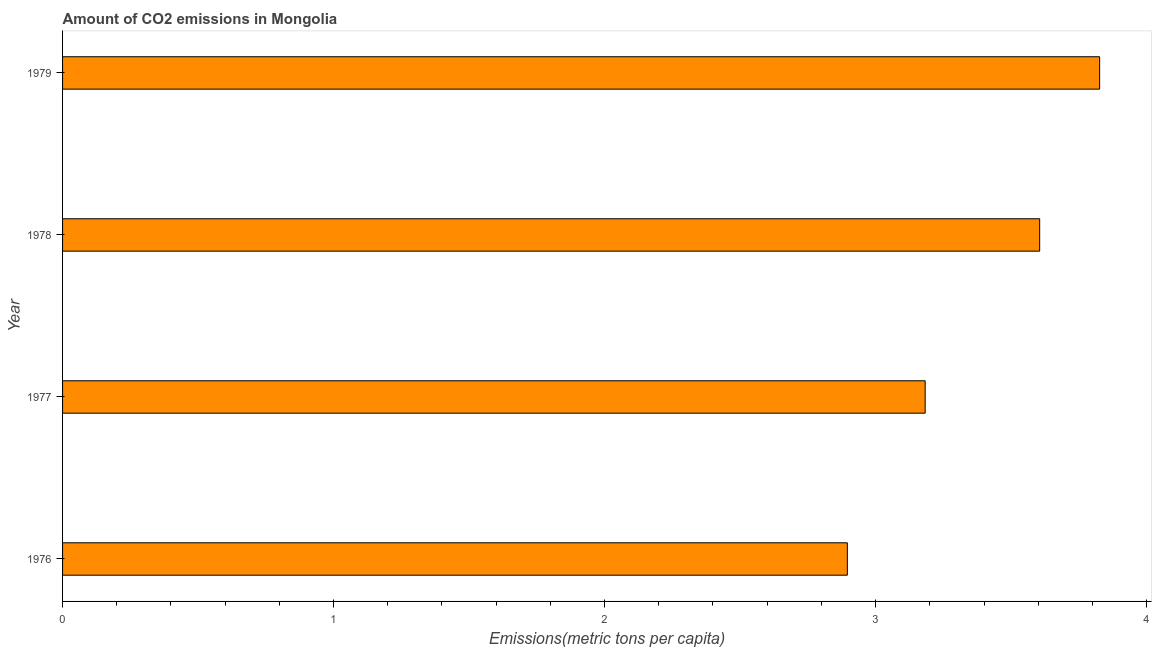Does the graph contain any zero values?
Keep it short and to the point. No. What is the title of the graph?
Offer a terse response. Amount of CO2 emissions in Mongolia. What is the label or title of the X-axis?
Offer a terse response. Emissions(metric tons per capita). What is the label or title of the Y-axis?
Make the answer very short. Year. What is the amount of co2 emissions in 1979?
Keep it short and to the point. 3.83. Across all years, what is the maximum amount of co2 emissions?
Provide a succinct answer. 3.83. Across all years, what is the minimum amount of co2 emissions?
Ensure brevity in your answer.  2.9. In which year was the amount of co2 emissions maximum?
Offer a terse response. 1979. In which year was the amount of co2 emissions minimum?
Give a very brief answer. 1976. What is the sum of the amount of co2 emissions?
Your answer should be compact. 13.51. What is the difference between the amount of co2 emissions in 1976 and 1978?
Ensure brevity in your answer.  -0.71. What is the average amount of co2 emissions per year?
Offer a very short reply. 3.38. What is the median amount of co2 emissions?
Your response must be concise. 3.39. In how many years, is the amount of co2 emissions greater than 1 metric tons per capita?
Give a very brief answer. 4. What is the ratio of the amount of co2 emissions in 1977 to that in 1979?
Provide a short and direct response. 0.83. Is the amount of co2 emissions in 1978 less than that in 1979?
Offer a terse response. Yes. Is the difference between the amount of co2 emissions in 1976 and 1979 greater than the difference between any two years?
Offer a very short reply. Yes. What is the difference between the highest and the second highest amount of co2 emissions?
Your response must be concise. 0.22. Is the sum of the amount of co2 emissions in 1977 and 1978 greater than the maximum amount of co2 emissions across all years?
Make the answer very short. Yes. In how many years, is the amount of co2 emissions greater than the average amount of co2 emissions taken over all years?
Your answer should be compact. 2. How many years are there in the graph?
Offer a terse response. 4. What is the difference between two consecutive major ticks on the X-axis?
Your answer should be very brief. 1. What is the Emissions(metric tons per capita) of 1976?
Your response must be concise. 2.9. What is the Emissions(metric tons per capita) of 1977?
Provide a short and direct response. 3.18. What is the Emissions(metric tons per capita) in 1978?
Your answer should be very brief. 3.61. What is the Emissions(metric tons per capita) in 1979?
Offer a very short reply. 3.83. What is the difference between the Emissions(metric tons per capita) in 1976 and 1977?
Your answer should be very brief. -0.29. What is the difference between the Emissions(metric tons per capita) in 1976 and 1978?
Make the answer very short. -0.71. What is the difference between the Emissions(metric tons per capita) in 1976 and 1979?
Give a very brief answer. -0.93. What is the difference between the Emissions(metric tons per capita) in 1977 and 1978?
Provide a succinct answer. -0.42. What is the difference between the Emissions(metric tons per capita) in 1977 and 1979?
Ensure brevity in your answer.  -0.64. What is the difference between the Emissions(metric tons per capita) in 1978 and 1979?
Ensure brevity in your answer.  -0.22. What is the ratio of the Emissions(metric tons per capita) in 1976 to that in 1977?
Provide a succinct answer. 0.91. What is the ratio of the Emissions(metric tons per capita) in 1976 to that in 1978?
Ensure brevity in your answer.  0.8. What is the ratio of the Emissions(metric tons per capita) in 1976 to that in 1979?
Give a very brief answer. 0.76. What is the ratio of the Emissions(metric tons per capita) in 1977 to that in 1978?
Keep it short and to the point. 0.88. What is the ratio of the Emissions(metric tons per capita) in 1977 to that in 1979?
Provide a short and direct response. 0.83. What is the ratio of the Emissions(metric tons per capita) in 1978 to that in 1979?
Your answer should be very brief. 0.94. 